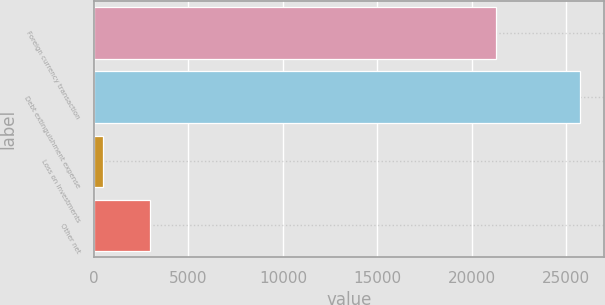<chart> <loc_0><loc_0><loc_500><loc_500><bar_chart><fcel>Foreign currency transaction<fcel>Debt extinguishment expense<fcel>Loss on investments<fcel>Other net<nl><fcel>21305<fcel>25720<fcel>462<fcel>2987.8<nl></chart> 